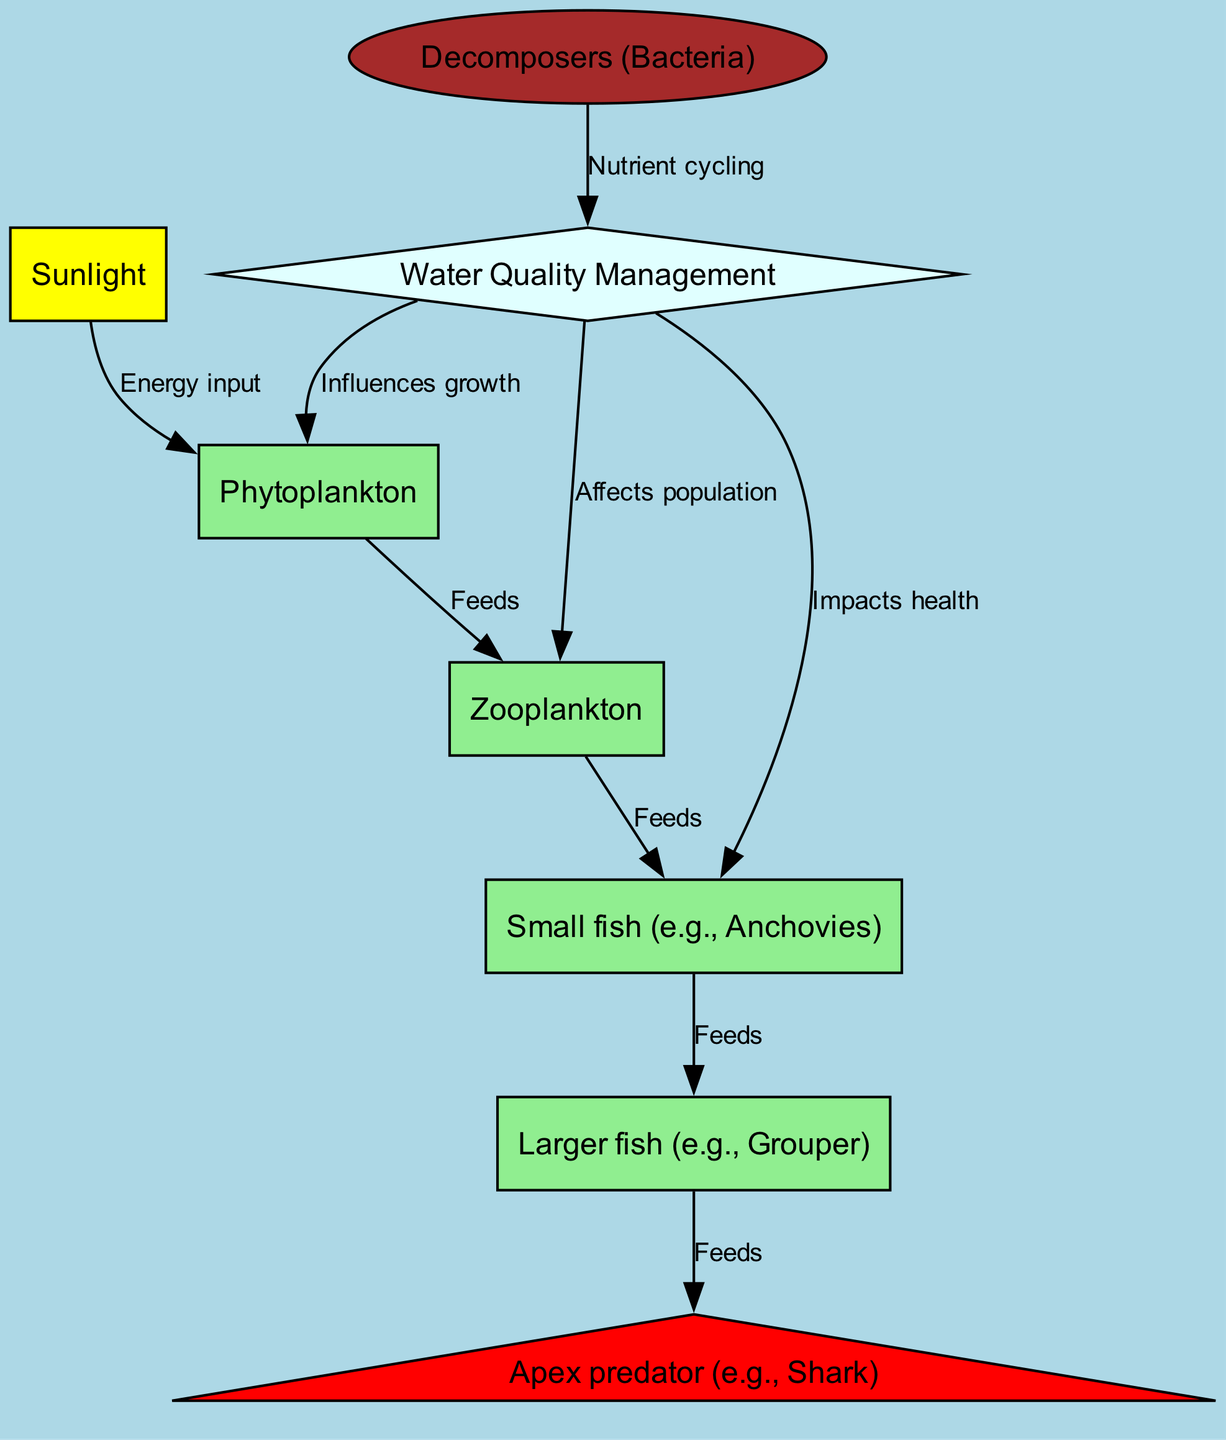What is the first element in the food chain? The diagram shows that sunlight is the starting point of the food chain as it is the first element connected in the flow.
Answer: Sunlight How many primary producers are present? The only primary producer in the diagram is phytoplankton, which is directly connected to sunlight, indicating its role in the food chain.
Answer: One What organism feeds on zooplankton? The diagram indicates that small fish, such as anchovies, directly feed on zooplankton, making it clear which organism occupies this position.
Answer: Small fish (e.g., Anchovies) What is the relationship between water quality and phytoplankton? The diagram shows a direct influence from water quality management to phytoplankton, indicating that water quality affects their growth.
Answer: Influences growth Which organisms are affected by water quality management? Water quality management affects phytoplankton, zooplankton, and small fish, as indicated by the connections drawn in the diagram to each of these elements.
Answer: Phytoplankton, Zooplankton, Small fish How does decomposers affect water quality? The diagram shows decomposers impacting water quality through nutrient cycling, thus indicating their role in maintaining the overall health of the aquatic ecosystem.
Answer: Nutrient cycling What is the apex predator in this diagram? The apex predator in the food chain is clearly labeled as a shark, which is located at the top of the food chain, indicating its role as the highest level consumer.
Answer: Apex predator (e.g., Shark) What role do zooplankton serve in the food chain? Zooplankton serve as the primary consumers, which are responsible for feeding on phytoplankton and providing energy to the small fish, making them crucial for the transfer of energy within the food chain.
Answer: Primary consumers How many links are there from sunlight to apex predator? The diagram outlines a series of connections beginning from sunlight that ultimately leads to the apex predator, counting a total of five links in the food chain: sunlight → phytoplankton → zooplankton → small fish → larger fish → apex predator.
Answer: Five 